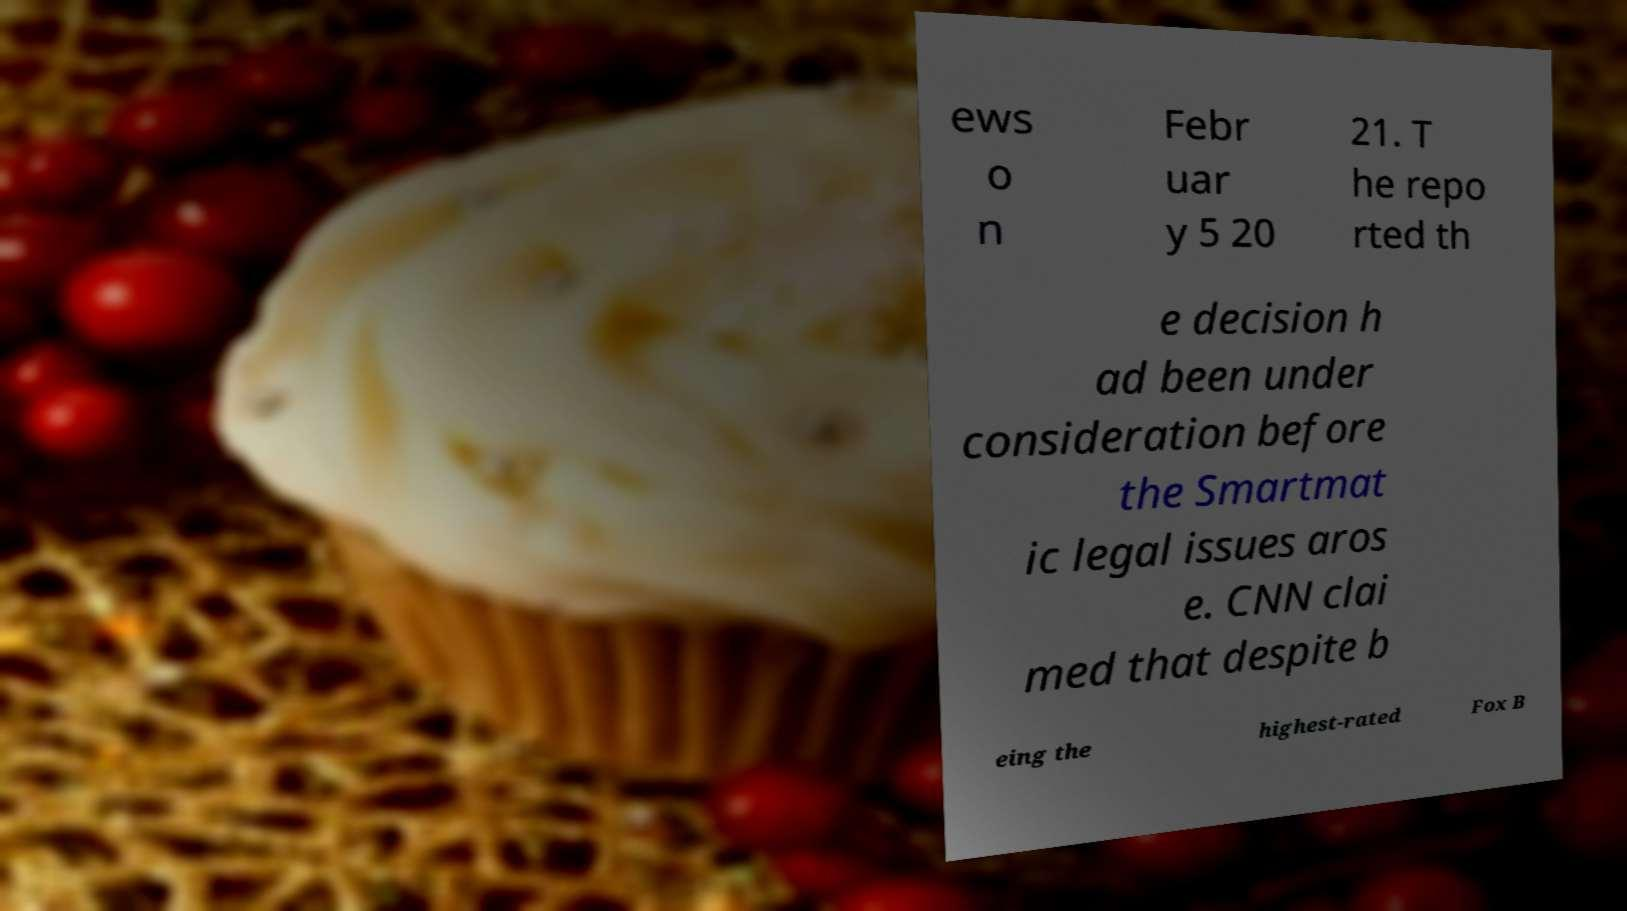There's text embedded in this image that I need extracted. Can you transcribe it verbatim? ews o n Febr uar y 5 20 21. T he repo rted th e decision h ad been under consideration before the Smartmat ic legal issues aros e. CNN clai med that despite b eing the highest-rated Fox B 